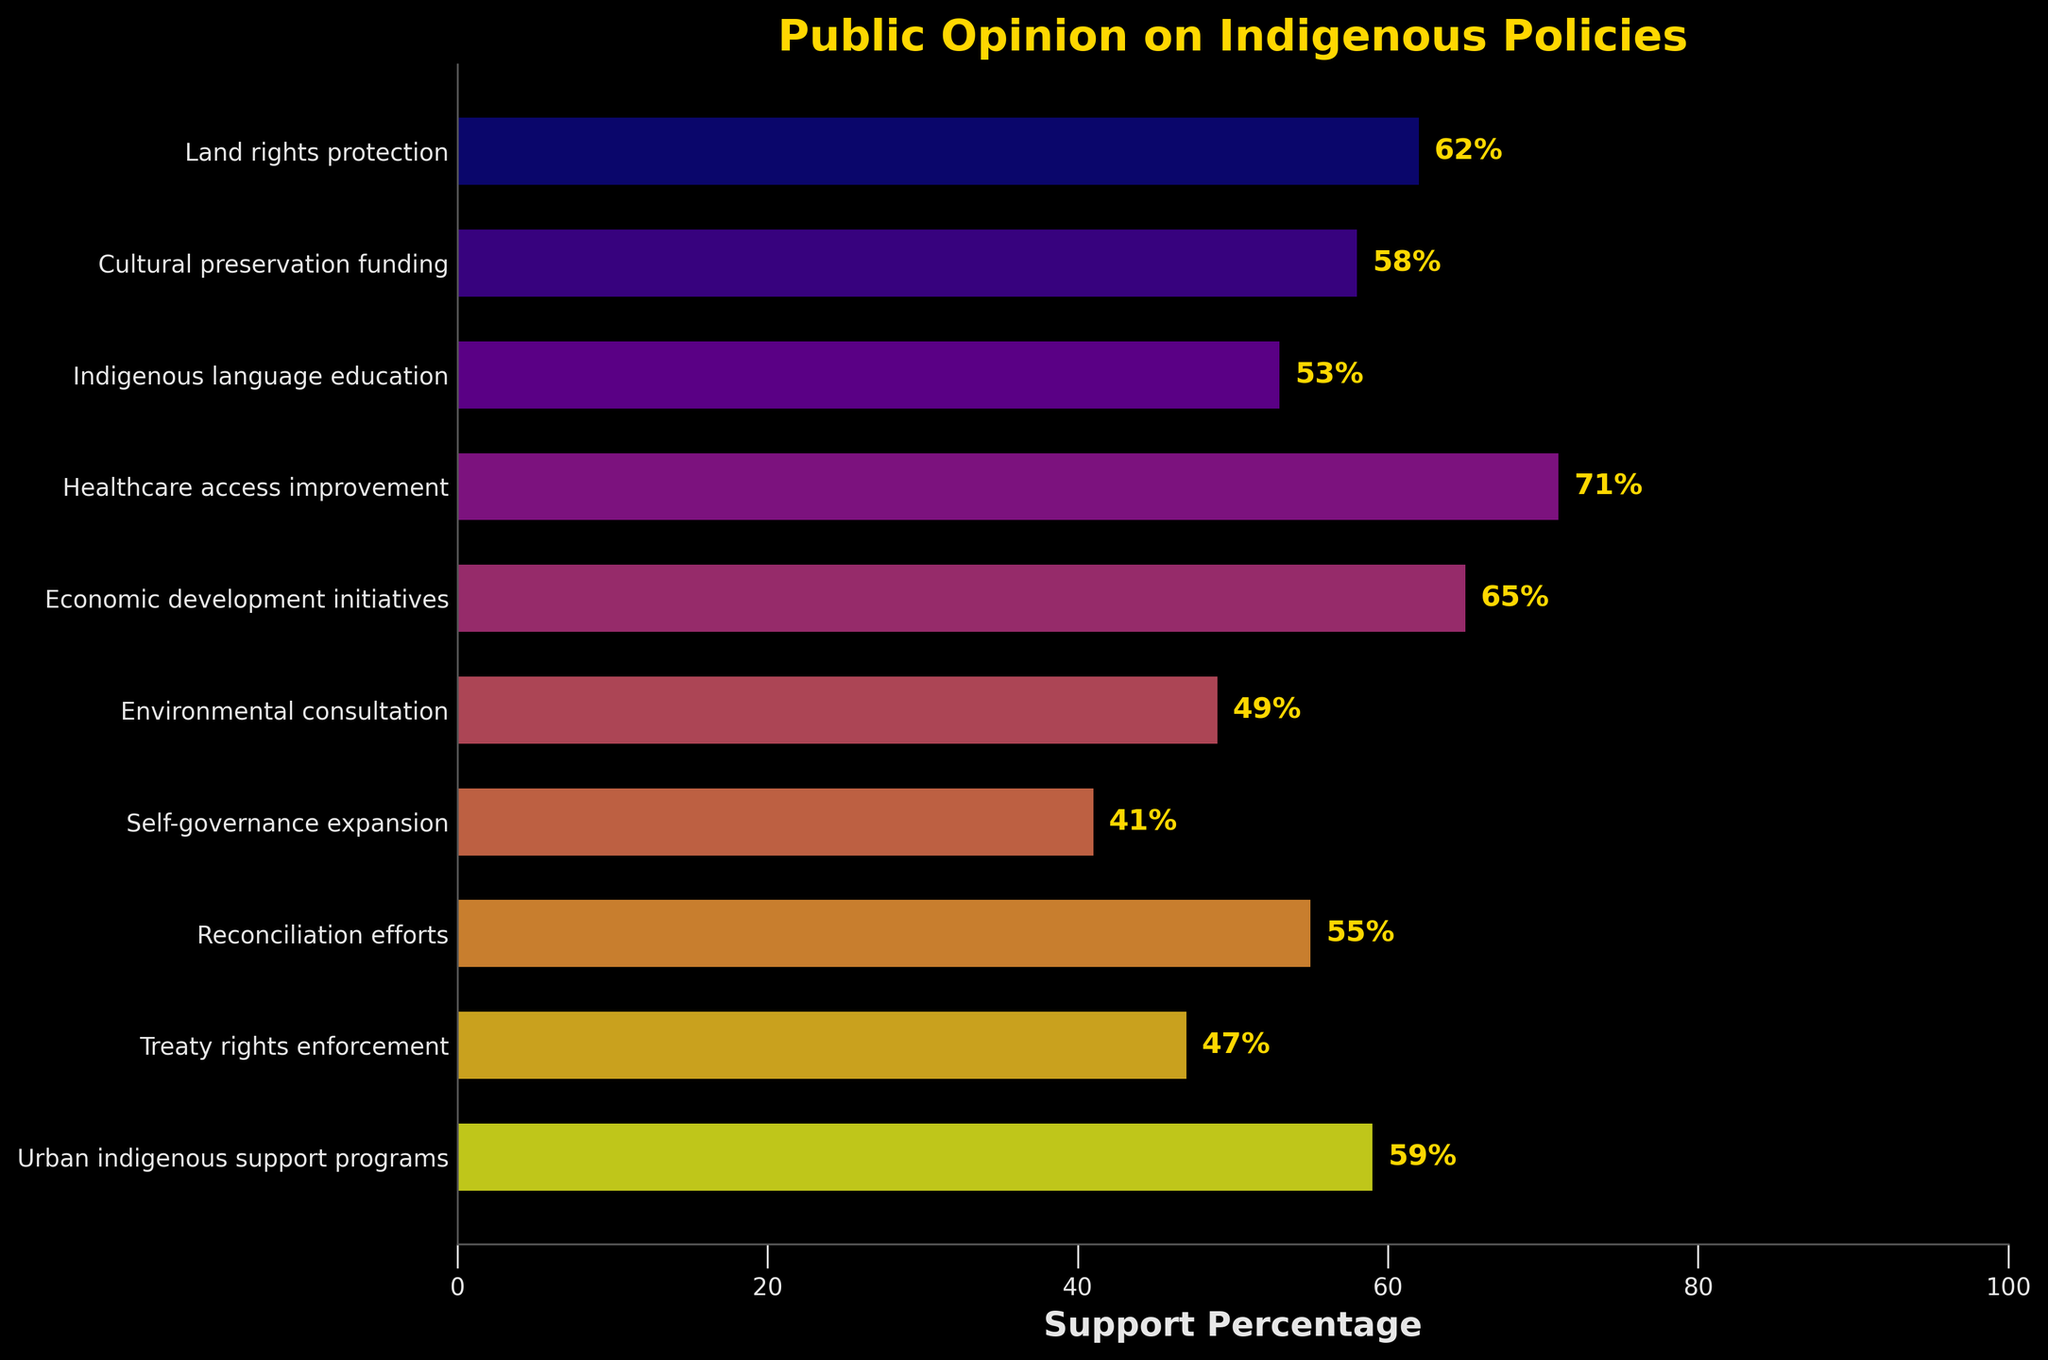Which policy has the highest support percentage? To find the policy with the highest support percentage, look at the bar that extends the farthest to the right. The Healthcare access improvement policy has the highest support percentage at 71%.
Answer: Healthcare access improvement Which policy has the lowest support percentage? To determine the policy with the lowest support percentage, look for the shortest bar. The Self-governance expansion policy has the lowest support percentage at 41%.
Answer: Self-governance expansion How much higher is the support percentage for Economic development initiatives compared to Environmental consultation? First, identify the support percentages: Economic development initiatives have 65%, and Environmental consultation has 49%. The difference is 65% - 49% = 16%.
Answer: 16% What is the average support percentage for Cultural preservation funding, Healthcare access improvement, and Reconciliation efforts? Calculate the average of the support percentages of the three policies: (58% + 71% + 55%) / 3 = 184% / 3 ≈ 61.33%.
Answer: 61.33% Which policies have a support percentage greater than 60%? Identify the bars with support percentages over 60%. The policies are Land rights protection (62%), Healthcare access improvement (71%), and Economic development initiatives (65%).
Answer: Land rights protection, Healthcare access improvement, Economic development initiatives How much lower is the support for Treaty rights enforcement compared to Indigenous language education? First, identify their support percentages: Treaty rights enforcement has 47%, and Indigenous language education has 53%. The difference is 53% - 47% = 6%.
Answer: 6% What is the combined support percentage for Urban indigenous support programs and Cultural preservation funding? Add the support percentages for both policies: 59% + 58% = 117%.
Answer: 117% Which policy falls in the middle in terms of support percentage? Arrange the policies by support percentage and find the middle value. The policy in the middle is Reconciliation efforts with 55%.
Answer: Reconciliation efforts What is the visual color gradient indicating in the chart? The color gradient, ranging from lighter to darker shades, visually represents the support percentages for each policy. Policies with higher support percentages have lighter colors, and those with lower percentages have darker colors.
Answer: Indicates support percentages from high to low 